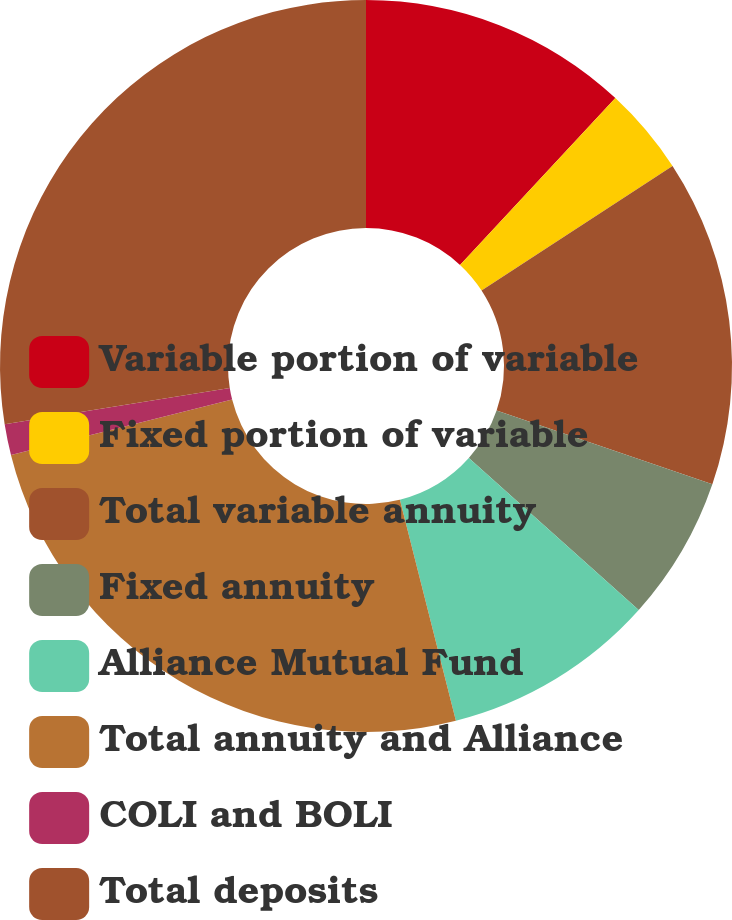<chart> <loc_0><loc_0><loc_500><loc_500><pie_chart><fcel>Variable portion of variable<fcel>Fixed portion of variable<fcel>Total variable annuity<fcel>Fixed annuity<fcel>Alliance Mutual Fund<fcel>Total annuity and Alliance<fcel>COLI and BOLI<fcel>Total deposits<nl><fcel>11.93%<fcel>3.87%<fcel>14.44%<fcel>6.38%<fcel>9.43%<fcel>25.04%<fcel>1.37%<fcel>27.54%<nl></chart> 